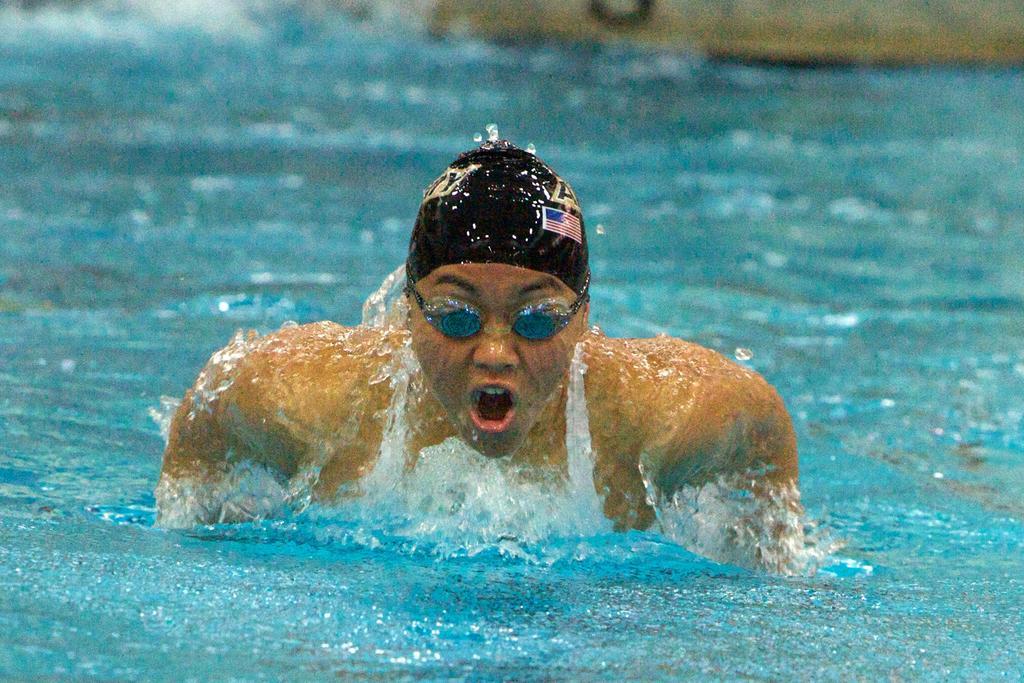Can you describe this image briefly? In this picture we can see a person with the google and the person is swimming in the water. 